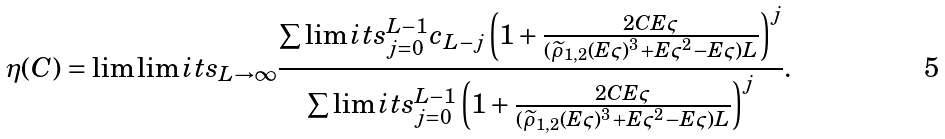Convert formula to latex. <formula><loc_0><loc_0><loc_500><loc_500>\eta ( C ) = \lim \lim i t s _ { L \to \infty } \frac { \sum \lim i t s _ { j = 0 } ^ { L - 1 } c _ { L - j } \left ( 1 + \frac { 2 C E \varsigma } { ( \widetilde { \rho } _ { 1 , 2 } ( E \varsigma ) ^ { 3 } + E \varsigma ^ { 2 } - E \varsigma ) L } \right ) ^ { j } } { \sum \lim i t s _ { j = 0 } ^ { L - 1 } \left ( 1 + \frac { 2 C E \varsigma } { ( \widetilde { \rho } _ { 1 , 2 } ( E \varsigma ) ^ { 3 } + E \varsigma ^ { 2 } - E \varsigma ) L } \right ) ^ { j } } .</formula> 